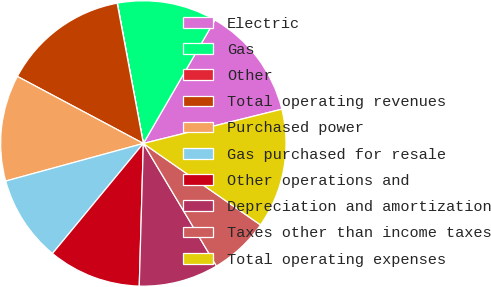Convert chart to OTSL. <chart><loc_0><loc_0><loc_500><loc_500><pie_chart><fcel>Electric<fcel>Gas<fcel>Other<fcel>Total operating revenues<fcel>Purchased power<fcel>Gas purchased for resale<fcel>Other operations and<fcel>Depreciation and amortization<fcel>Taxes other than income taxes<fcel>Total operating expenses<nl><fcel>12.78%<fcel>11.28%<fcel>0.02%<fcel>14.28%<fcel>12.03%<fcel>9.77%<fcel>10.53%<fcel>9.02%<fcel>6.77%<fcel>13.53%<nl></chart> 